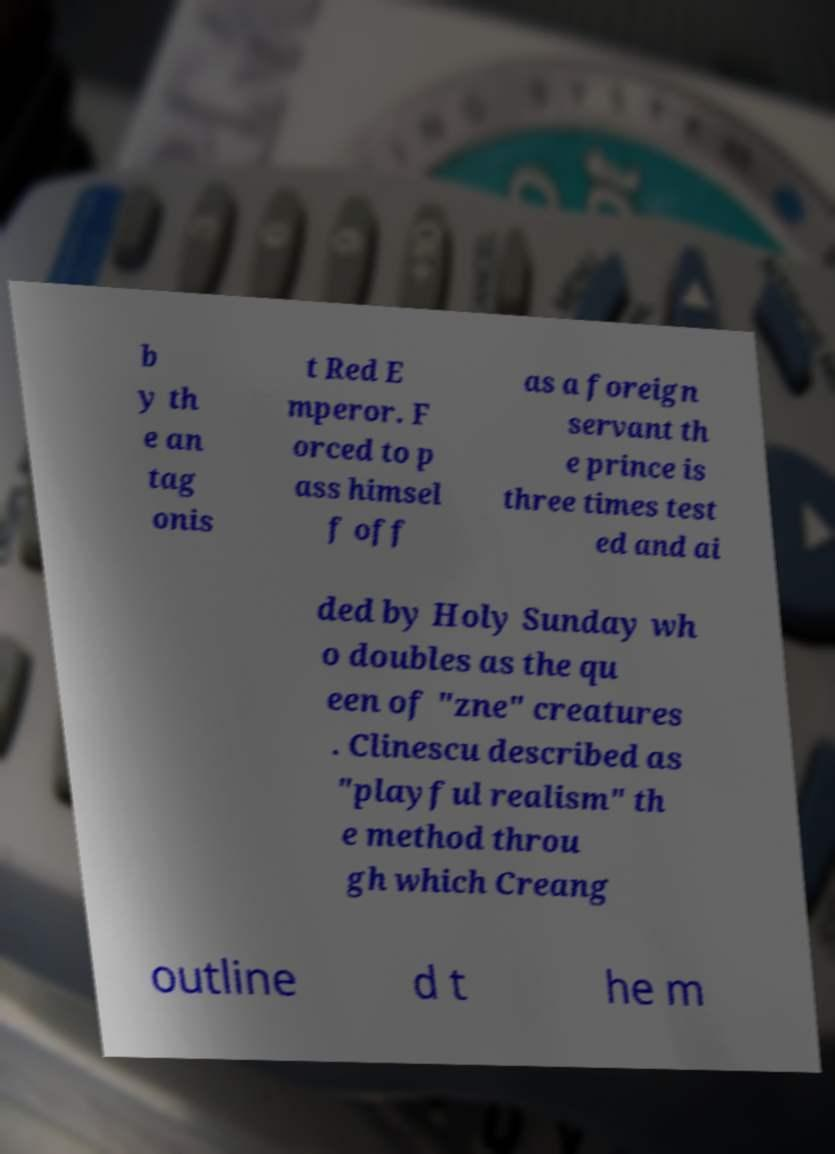What messages or text are displayed in this image? I need them in a readable, typed format. b y th e an tag onis t Red E mperor. F orced to p ass himsel f off as a foreign servant th e prince is three times test ed and ai ded by Holy Sunday wh o doubles as the qu een of "zne" creatures . Clinescu described as "playful realism" th e method throu gh which Creang outline d t he m 